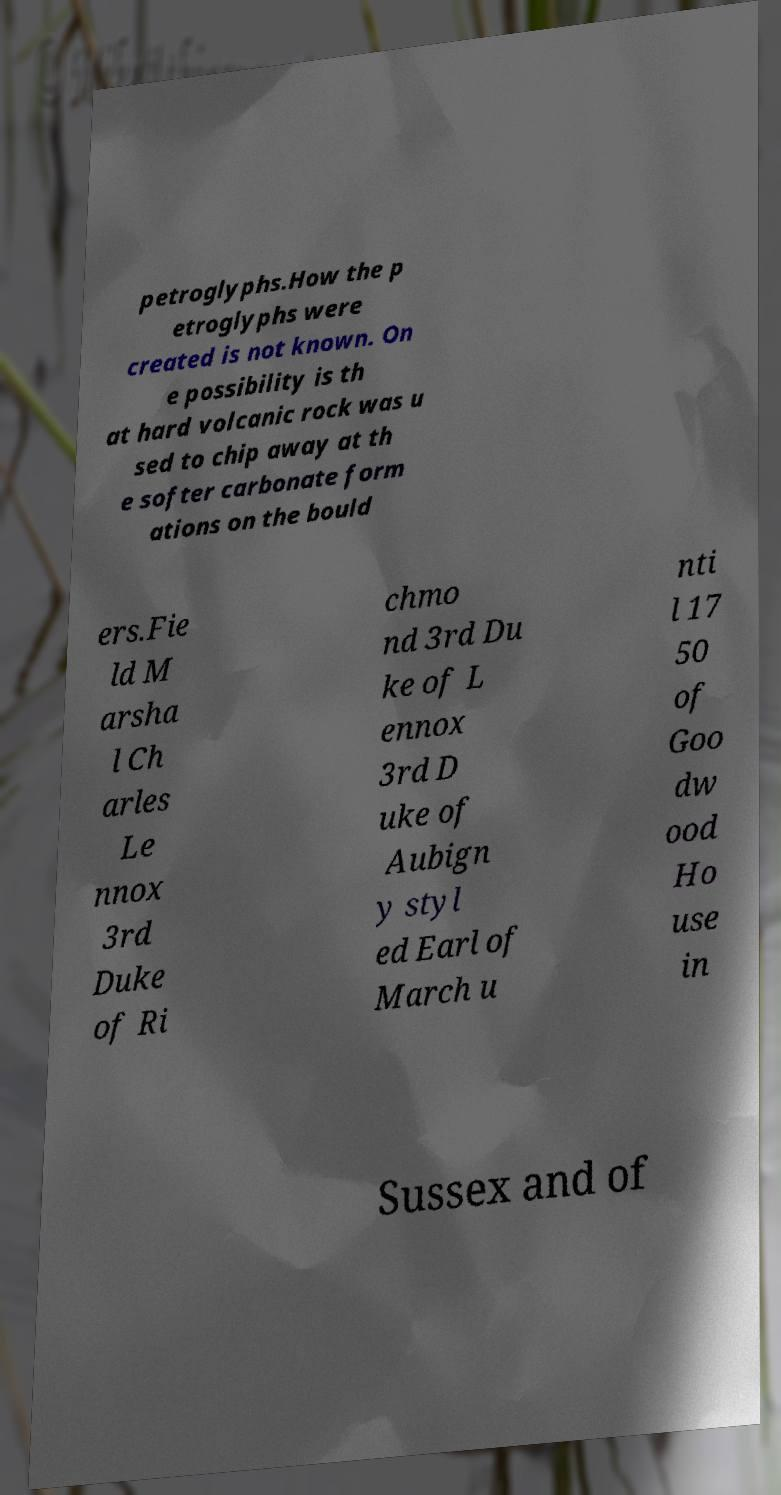There's text embedded in this image that I need extracted. Can you transcribe it verbatim? petroglyphs.How the p etroglyphs were created is not known. On e possibility is th at hard volcanic rock was u sed to chip away at th e softer carbonate form ations on the bould ers.Fie ld M arsha l Ch arles Le nnox 3rd Duke of Ri chmo nd 3rd Du ke of L ennox 3rd D uke of Aubign y styl ed Earl of March u nti l 17 50 of Goo dw ood Ho use in Sussex and of 